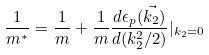<formula> <loc_0><loc_0><loc_500><loc_500>\frac { 1 } { m ^ { * } } = \frac { 1 } { m } + \frac { 1 } { m } \frac { d \epsilon _ { p } ( \vec { k _ { 2 } } ) } { d ( k _ { 2 } ^ { 2 } / 2 ) } | _ { k _ { 2 } = 0 }</formula> 